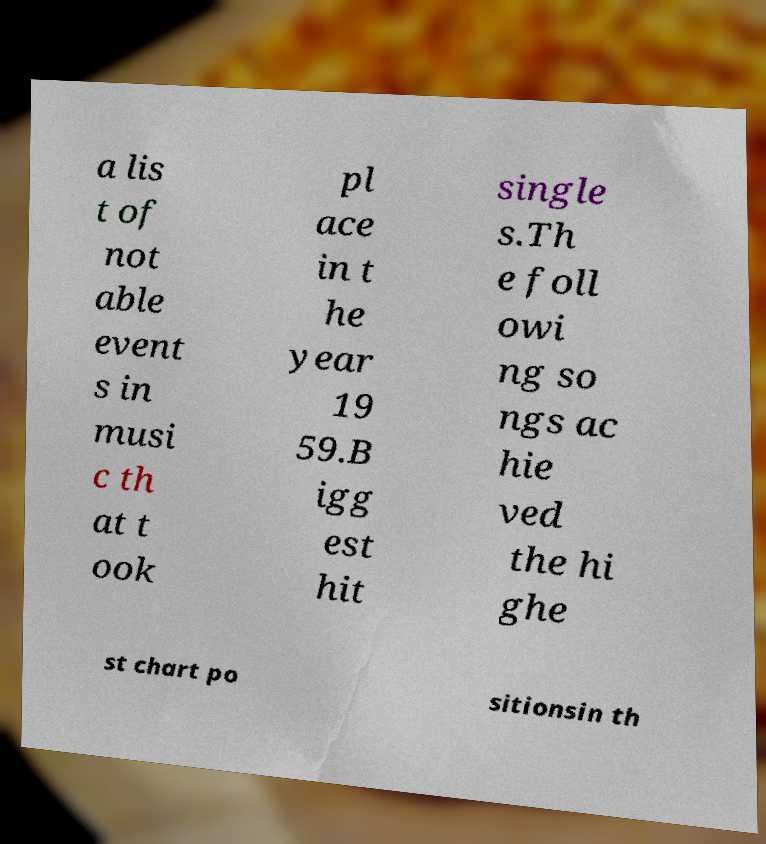I need the written content from this picture converted into text. Can you do that? a lis t of not able event s in musi c th at t ook pl ace in t he year 19 59.B igg est hit single s.Th e foll owi ng so ngs ac hie ved the hi ghe st chart po sitionsin th 